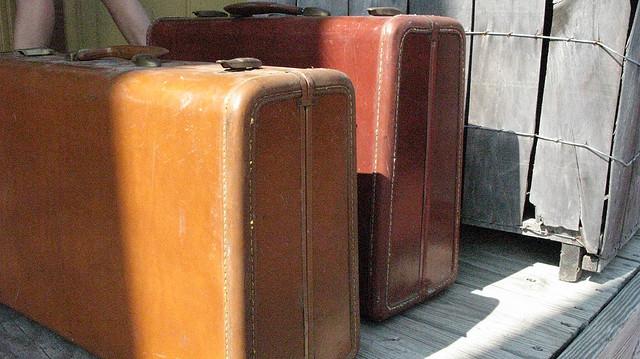Were these built to last?
Concise answer only. Yes. What is peeling off of the suitcase?
Quick response, please. Leather. Are there things sticking out of the luggage?
Short answer required. No. What are these two objects made of?
Write a very short answer. Leather. What are the suitcases sitting on?
Quick response, please. Wood. 